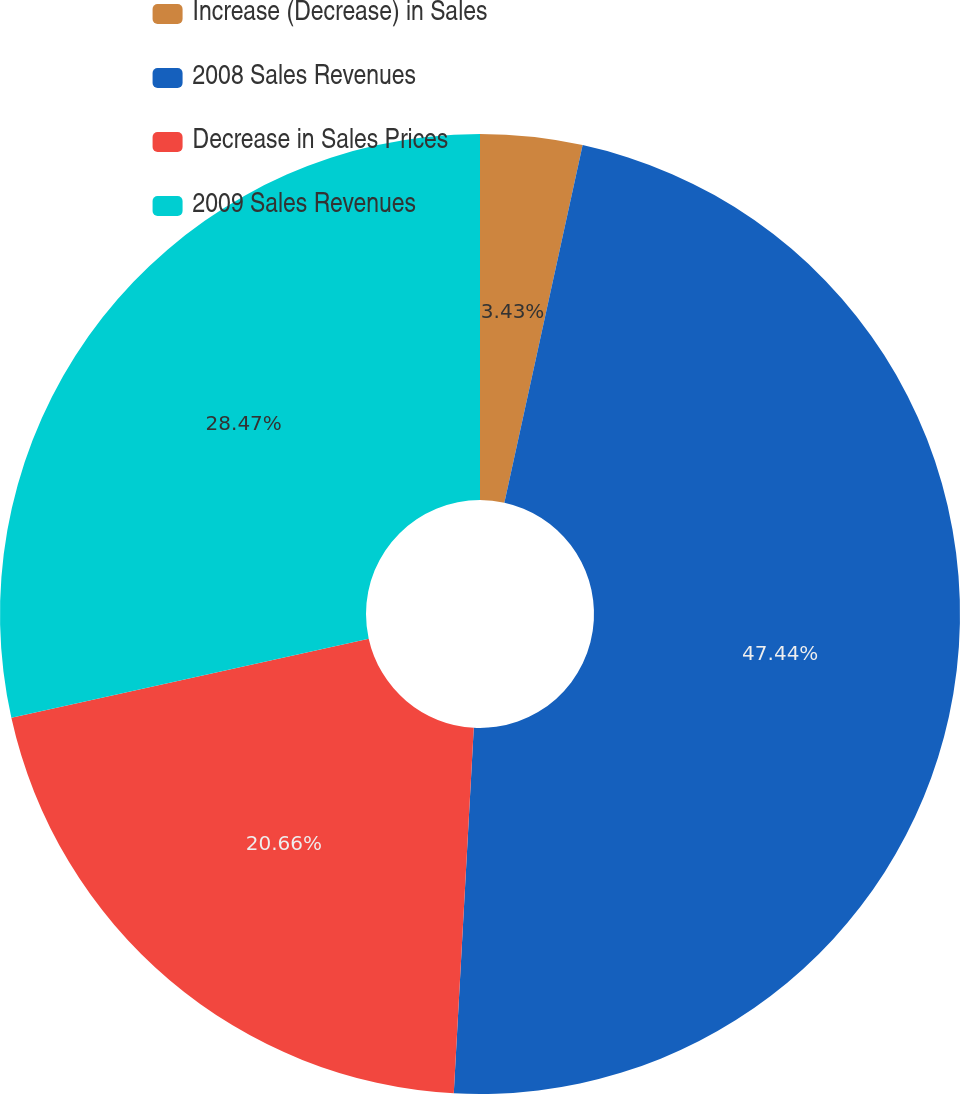Convert chart. <chart><loc_0><loc_0><loc_500><loc_500><pie_chart><fcel>Increase (Decrease) in Sales<fcel>2008 Sales Revenues<fcel>Decrease in Sales Prices<fcel>2009 Sales Revenues<nl><fcel>3.43%<fcel>47.44%<fcel>20.66%<fcel>28.47%<nl></chart> 